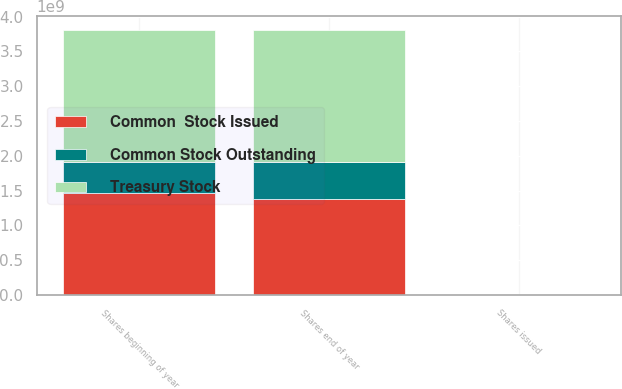Convert chart. <chart><loc_0><loc_0><loc_500><loc_500><stacked_bar_chart><ecel><fcel>Shares beginning of year<fcel>Shares issued<fcel>Shares end of year<nl><fcel>Treasury Stock<fcel>1.90665e+09<fcel>25803<fcel>1.90667e+09<nl><fcel>Common Stock Outstanding<fcel>4.42582e+08<fcel>15748<fcel>5.30745e+08<nl><fcel>Common  Stock Issued<fcel>1.46406e+09<fcel>41551<fcel>1.37593e+09<nl></chart> 